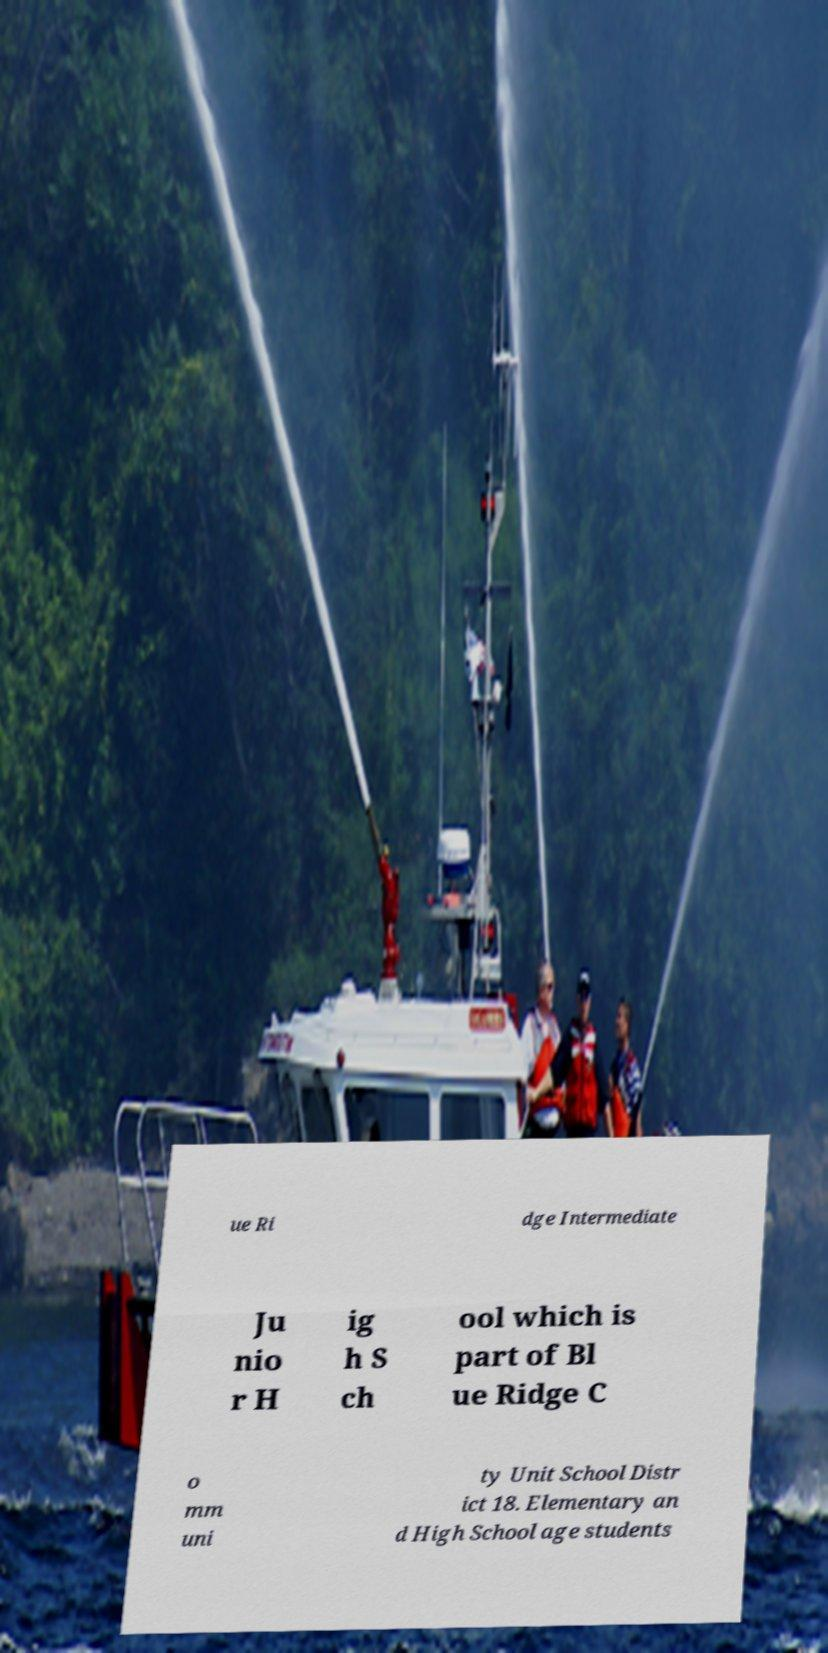Please read and relay the text visible in this image. What does it say? ue Ri dge Intermediate Ju nio r H ig h S ch ool which is part of Bl ue Ridge C o mm uni ty Unit School Distr ict 18. Elementary an d High School age students 